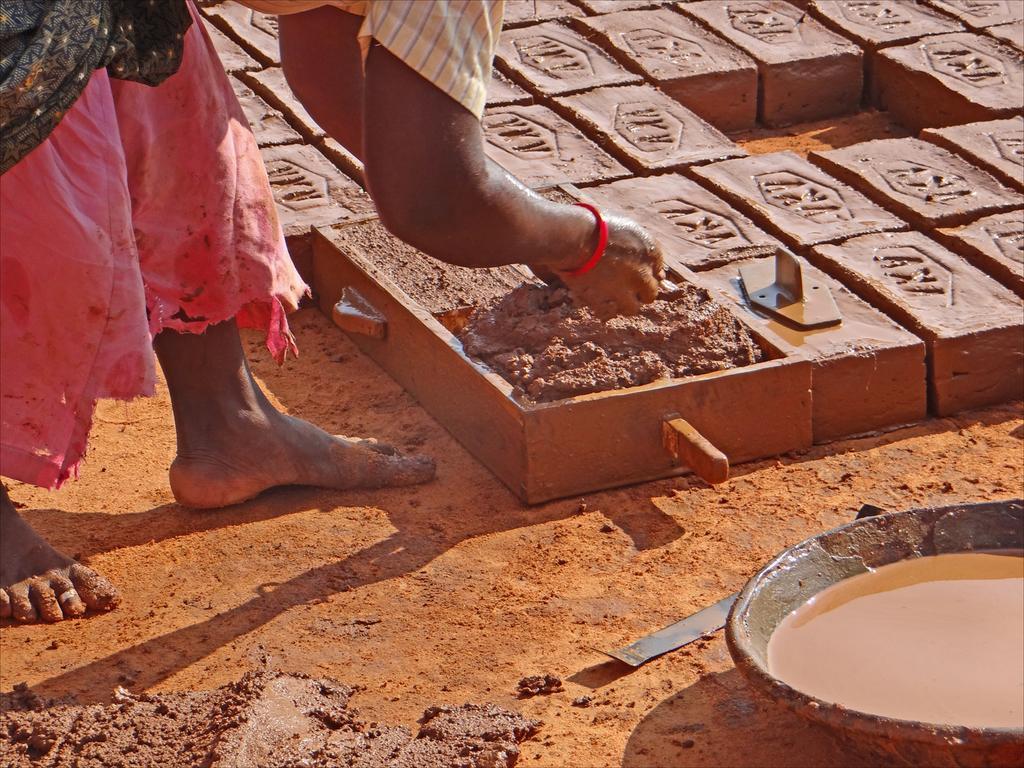Please provide a concise description of this image. In this picture there is a woman standing and holding the mud. There are bricks and there is a tool on the brick. In the foreground there is water. At the bottom there is a tool and there is mud. 